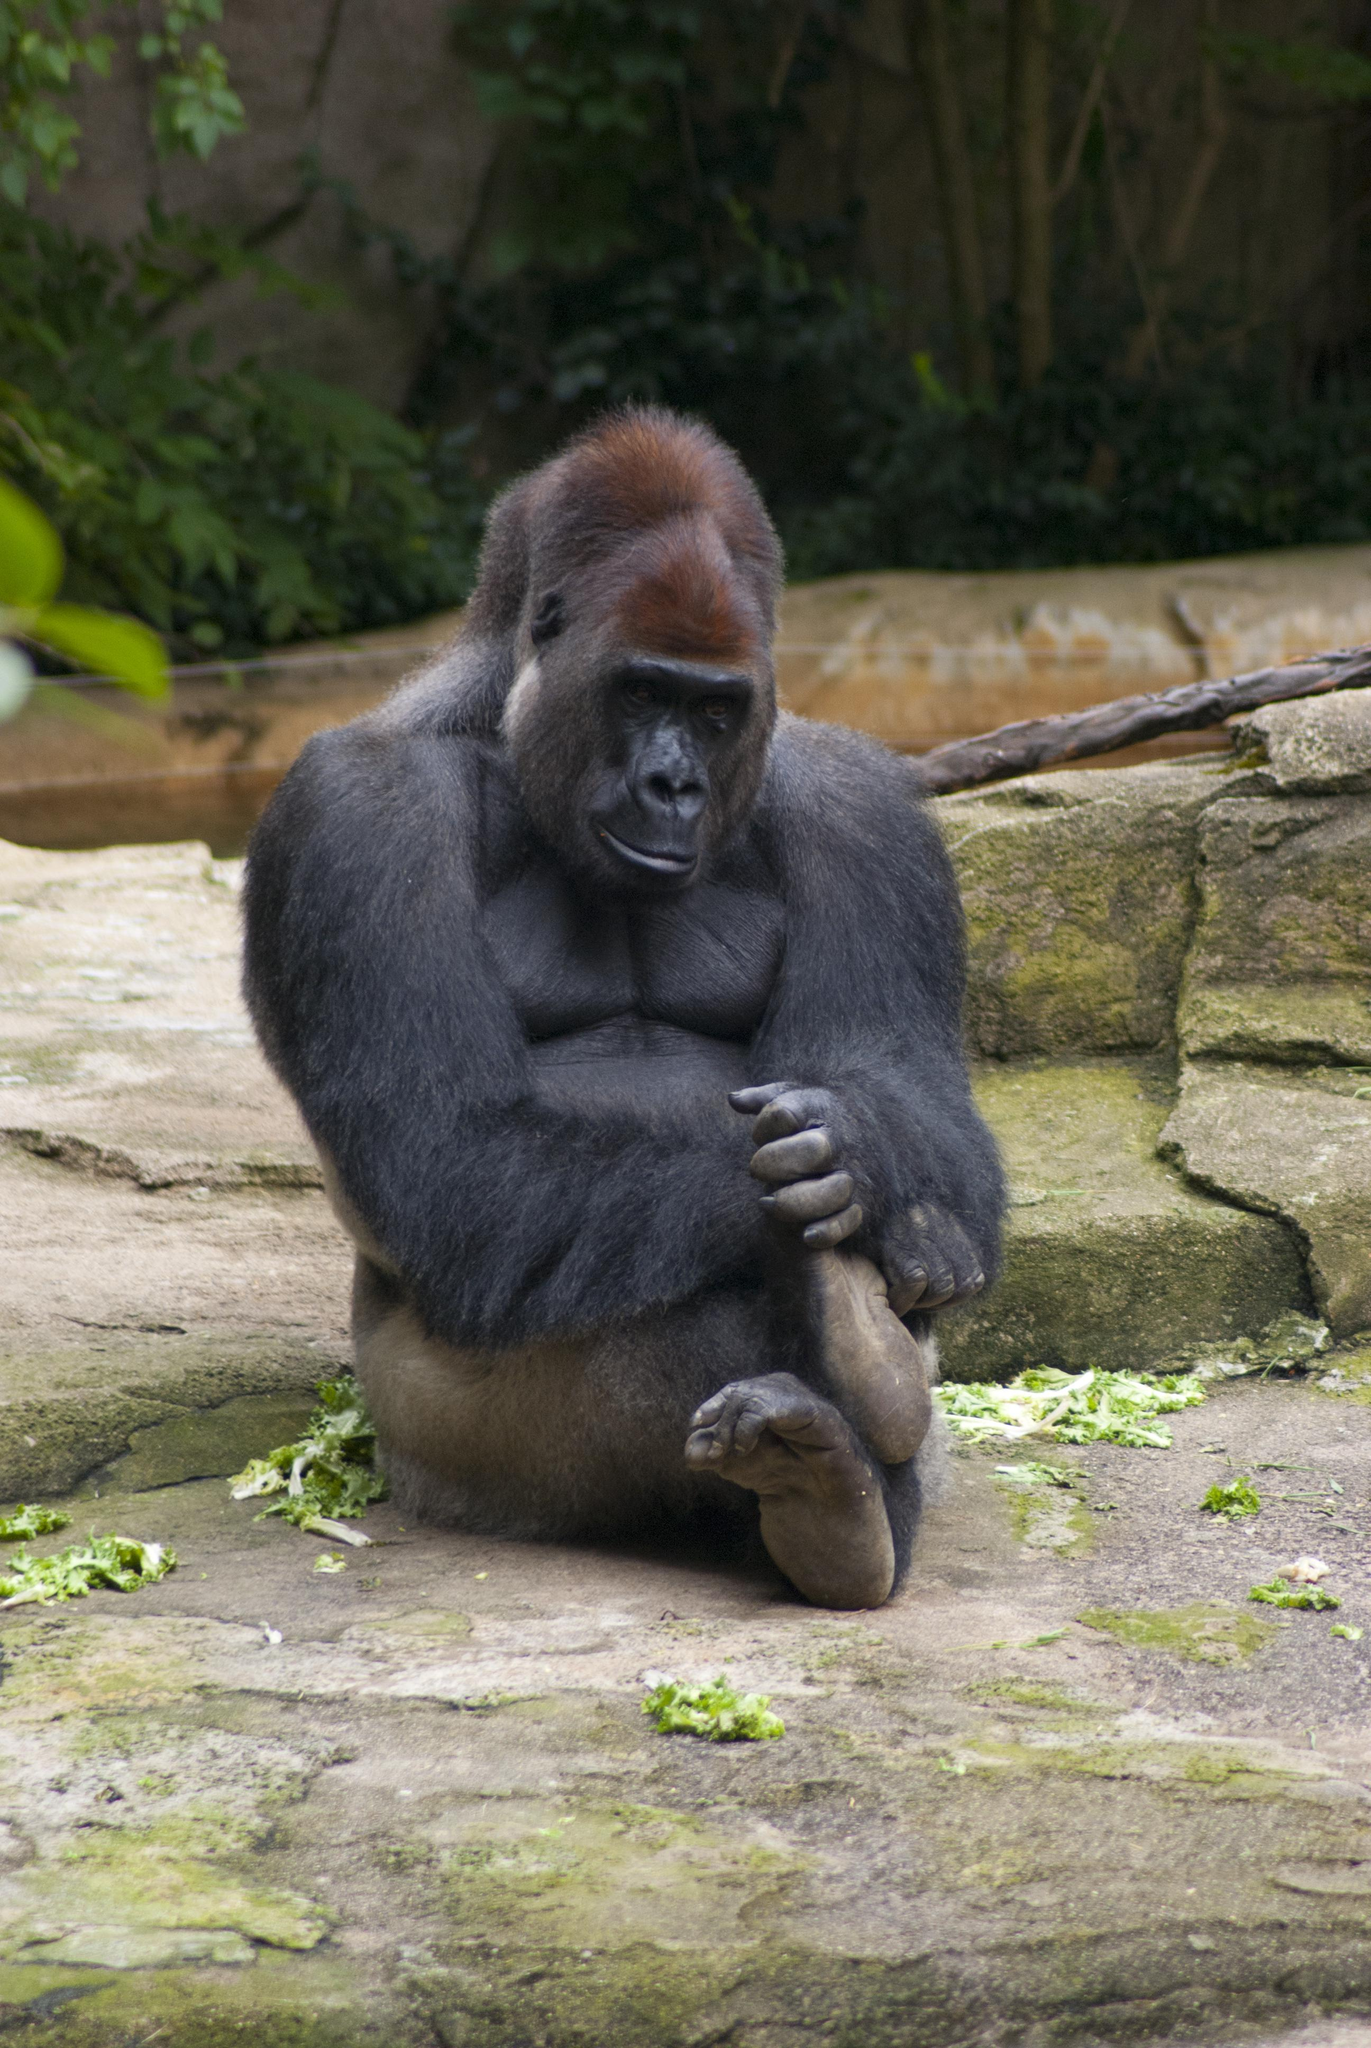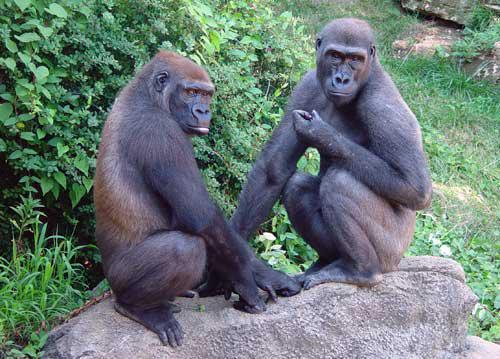The first image is the image on the left, the second image is the image on the right. Examine the images to the left and right. Is the description "Exactly one of the ape's feet can be seen in the image on the right." accurate? Answer yes or no. No. 